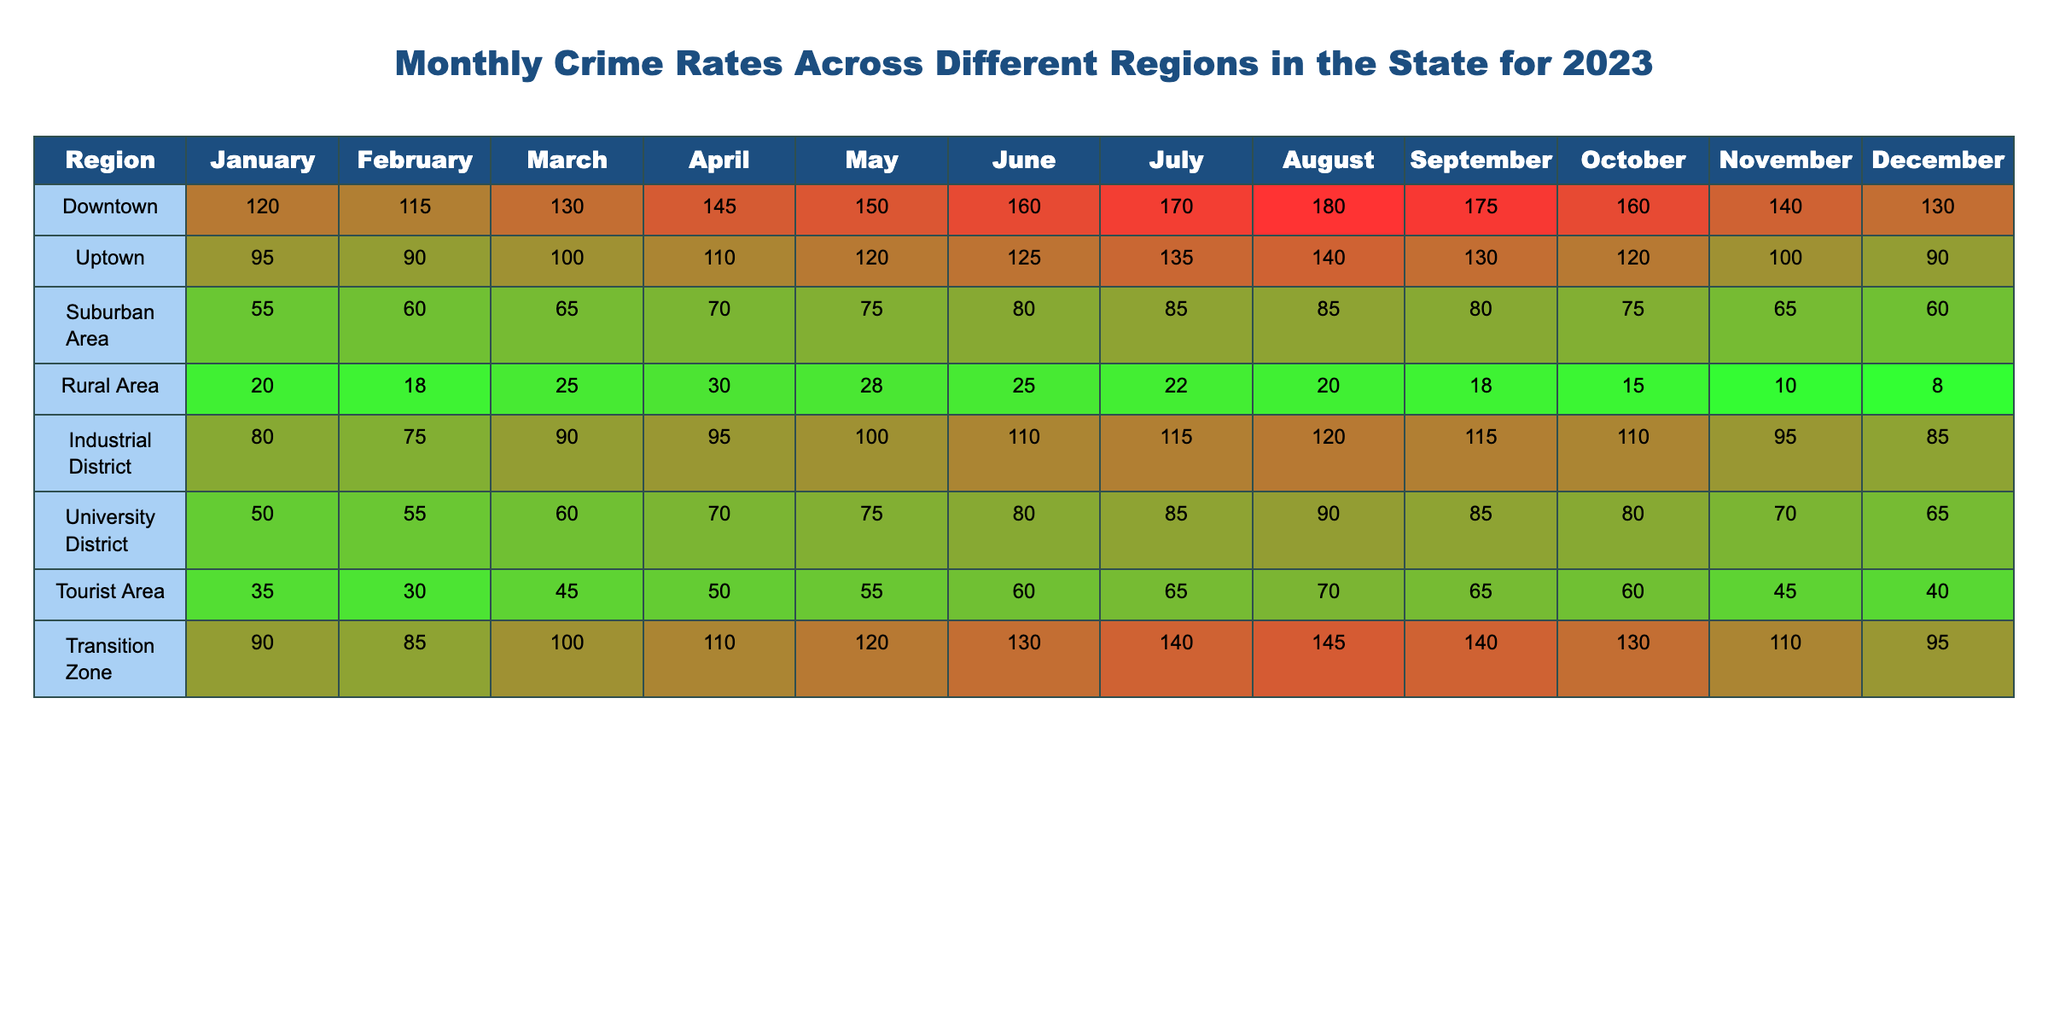What is the total crime rate in Downtown for the year 2023? To find the total crime rate in Downtown, we sum the monthly values: 120 + 115 + 130 + 145 + 150 + 160 + 170 + 180 + 175 + 160 + 140 + 130 = 1,635.
Answer: 1,635 Which region had the lowest crime rate in May? In May, the crime rates are: Downtown (150), Uptown (120), Suburban Area (75), Rural Area (28), Industrial District (100), University District (75), Tourist Area (55), Transition Zone (120). The lowest is Rural Area (28).
Answer: Rural Area What is the average crime rate for Uptown in the first half of the year (January to June)? The months to consider are January (95), February (90), March (100), April (110), May (120), and June (125). The total for these months is 95 + 90 + 100 + 110 + 120 + 125 = 640, divided by 6 gives an average of 640 / 6 ≈ 106.67.
Answer: 106.67 Does the University District have a higher crime rate in March than the Tourist Area? University District in March has a crime rate of 60, while Tourist Area has 45. Since 60 > 45, it is true that the University District has a higher rate.
Answer: Yes Which region experienced the highest increase in crime rate from June to July? We look at the increases: Downtown (160 to 170 = +10), Uptown (125 to 135 = +10), Suburban Area (80 to 85 = +5), Rural Area (25 to 22 = -3), Industrial District (110 to 115 = +5), University District (80 to 85 = +5), Tourist Area (60 to 65 = +5), Transition Zone (130 to 140 = +10). The highest increase is 10, shared by Downtown, Uptown, and Transition Zone.
Answer: Downtown, Uptown, and Transition Zone What is the total crime rate for Rural Area in the last quarter of the year? The months to take into account are October (15), November (10), and December (8). Adding these gives us 15 + 10 + 8 = 33.
Answer: 33 Which region has the highest crime rate during the summer months (June, July, August)? The monthly crime rates in summer are: Downtown (160, 170, 180), Uptown (125, 135, 140), Suburban Area (80, 85, 85), Rural Area (25, 22, 20), Industrial District (110, 115, 120), University District (80, 85, 90), Tourist Area (60, 65, 70), Transition Zone (130, 140, 145). The totals are: Downtown (510), Uptown (400), Suburban Area (250), Rural Area (67), Industrial District (345), University District (255), Tourist Area (195), Transition Zone (415). Downtown has the highest total of 510.
Answer: Downtown What is the median crime rate for Suburban Area across all months? The monthly rates for Suburban Area are: 55, 60, 65, 70, 75, 80, 85, 85, 80, 75, 65, 60. Sorting these gives: 55, 60, 60, 65, 65, 70, 75, 75, 80, 80, 85, 85. Since there are 12 numbers, the median is the average of the 6th and 7th values: (70 + 75) / 2 = 72.5.
Answer: 72.5 How many regions had a crime rate above 100 in October? In October, crime rates are: Downtown (160), Uptown (120), Suburban Area (75), Rural Area (15), Industrial District (110), University District (80), Tourist Area (60), Transition Zone (130). The regions with rates above 100 are Downtown, Uptown, Industrial District, and Transition Zone, totaling 4 regions.
Answer: 4 